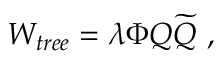<formula> <loc_0><loc_0><loc_500><loc_500>W _ { t r e e } = \lambda \Phi Q { \widetilde { Q } } ,</formula> 